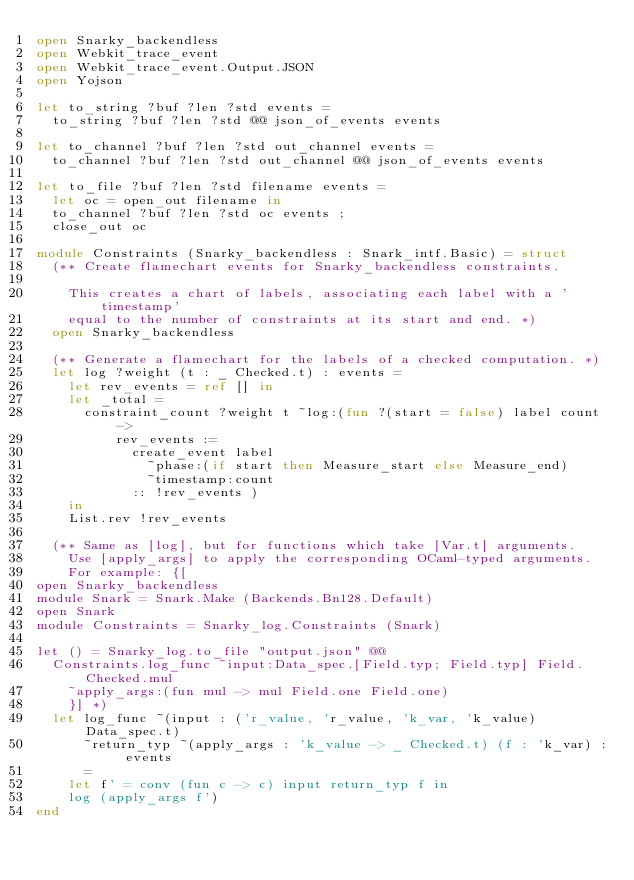Convert code to text. <code><loc_0><loc_0><loc_500><loc_500><_OCaml_>open Snarky_backendless
open Webkit_trace_event
open Webkit_trace_event.Output.JSON
open Yojson

let to_string ?buf ?len ?std events =
  to_string ?buf ?len ?std @@ json_of_events events

let to_channel ?buf ?len ?std out_channel events =
  to_channel ?buf ?len ?std out_channel @@ json_of_events events

let to_file ?buf ?len ?std filename events =
  let oc = open_out filename in
  to_channel ?buf ?len ?std oc events ;
  close_out oc

module Constraints (Snarky_backendless : Snark_intf.Basic) = struct
  (** Create flamechart events for Snarky_backendless constraints.

    This creates a chart of labels, associating each label with a 'timestamp'
    equal to the number of constraints at its start and end. *)
  open Snarky_backendless

  (** Generate a flamechart for the labels of a checked computation. *)
  let log ?weight (t : _ Checked.t) : events =
    let rev_events = ref [] in
    let _total =
      constraint_count ?weight t ~log:(fun ?(start = false) label count ->
          rev_events :=
            create_event label
              ~phase:(if start then Measure_start else Measure_end)
              ~timestamp:count
            :: !rev_events )
    in
    List.rev !rev_events

  (** Same as [log], but for functions which take [Var.t] arguments.
    Use [apply_args] to apply the corresponding OCaml-typed arguments.
    For example: {[
open Snarky_backendless
module Snark = Snark.Make (Backends.Bn128.Default)
open Snark
module Constraints = Snarky_log.Constraints (Snark)

let () = Snarky_log.to_file "output.json" @@
  Constraints.log_func ~input:Data_spec.[Field.typ; Field.typ] Field.Checked.mul
    ~apply_args:(fun mul -> mul Field.one Field.one)
    }] *)
  let log_func ~(input : ('r_value, 'r_value, 'k_var, 'k_value) Data_spec.t)
      ~return_typ ~(apply_args : 'k_value -> _ Checked.t) (f : 'k_var) : events
      =
    let f' = conv (fun c -> c) input return_typ f in
    log (apply_args f')
end
</code> 